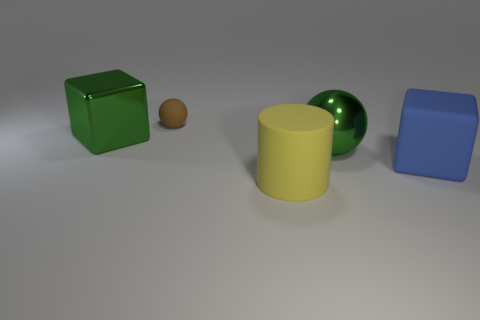Add 1 large matte cubes. How many objects exist? 6 Subtract all cylinders. How many objects are left? 4 Subtract 0 gray spheres. How many objects are left? 5 Subtract all brown metallic blocks. Subtract all shiny cubes. How many objects are left? 4 Add 2 big blocks. How many big blocks are left? 4 Add 4 rubber cylinders. How many rubber cylinders exist? 5 